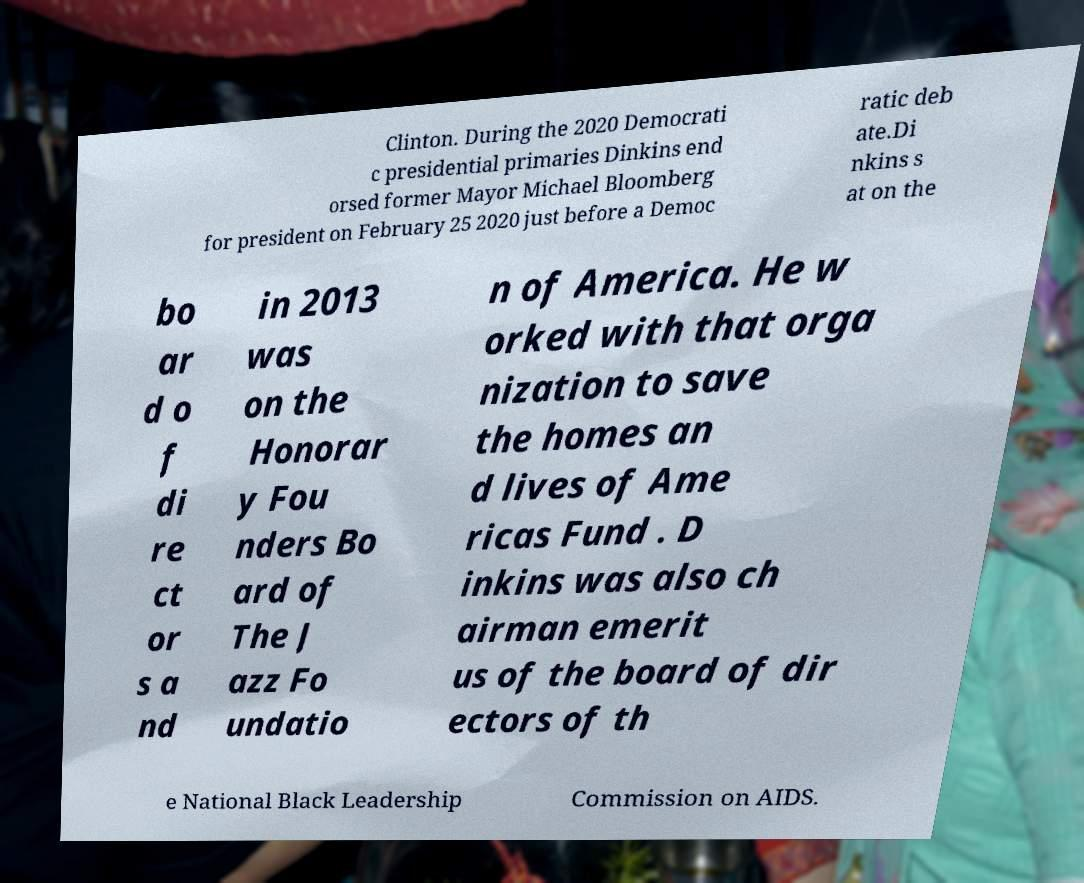Can you accurately transcribe the text from the provided image for me? Clinton. During the 2020 Democrati c presidential primaries Dinkins end orsed former Mayor Michael Bloomberg for president on February 25 2020 just before a Democ ratic deb ate.Di nkins s at on the bo ar d o f di re ct or s a nd in 2013 was on the Honorar y Fou nders Bo ard of The J azz Fo undatio n of America. He w orked with that orga nization to save the homes an d lives of Ame ricas Fund . D inkins was also ch airman emerit us of the board of dir ectors of th e National Black Leadership Commission on AIDS. 